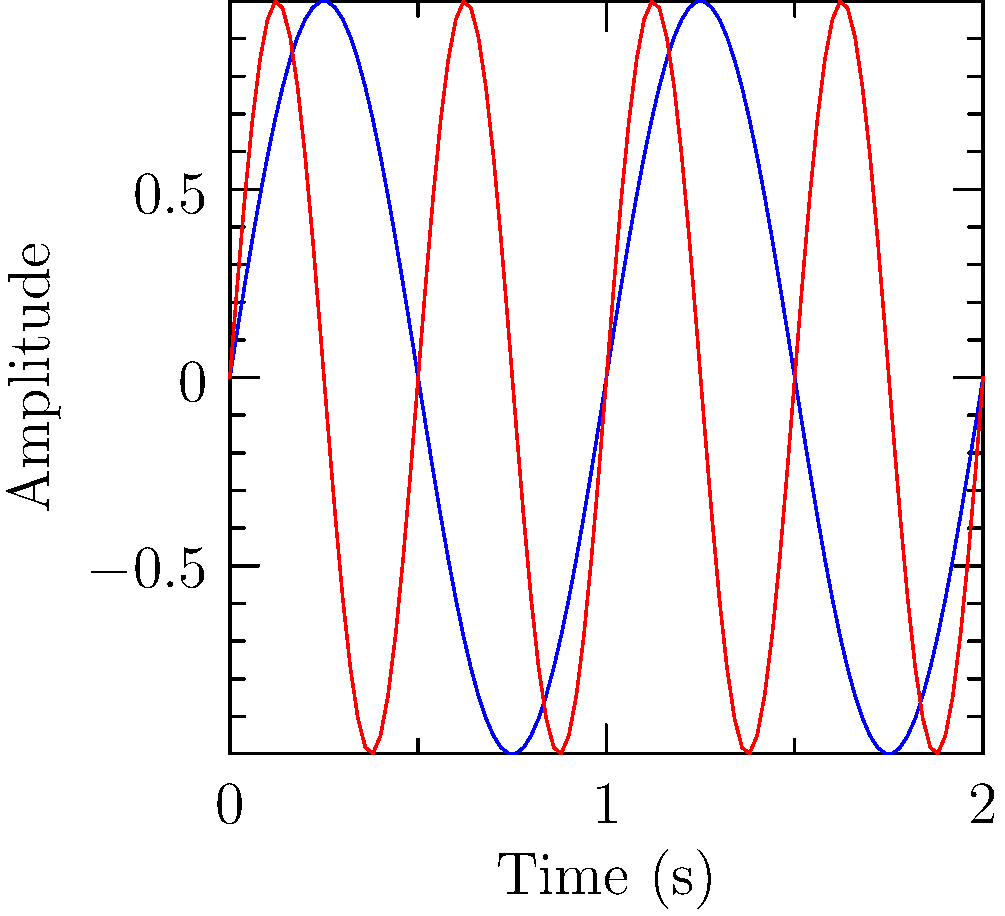As a retired musician, you're familiar with sound frequencies. The graph shows two sine waves representing different frequencies. The blue wave represents a 440 Hz tone (A4), while the red wave represents an 880 Hz tone (A5). How many complete cycles does the 880 Hz wave complete in the time it takes the 440 Hz wave to complete one full cycle? To solve this problem, let's follow these steps:

1. Recall that frequency is measured in cycles per second (Hz).
2. The blue wave (440 Hz) completes one full cycle in the given time period.
3. The time period for one cycle of the 440 Hz wave is:
   $$T_{440} = \frac{1}{440} \approx 0.00227 \text{ seconds}$$
4. In this same time period, the 880 Hz wave will complete:
   $$\text{Number of cycles} = 880 \text{ Hz} \times 0.00227 \text{ s} = 2$$
5. We can also observe this visually: in the time it takes the blue wave to complete one cycle, the red wave completes two full cycles.

Therefore, the 880 Hz wave completes 2 cycles in the time it takes the 440 Hz wave to complete one cycle.
Answer: 2 cycles 